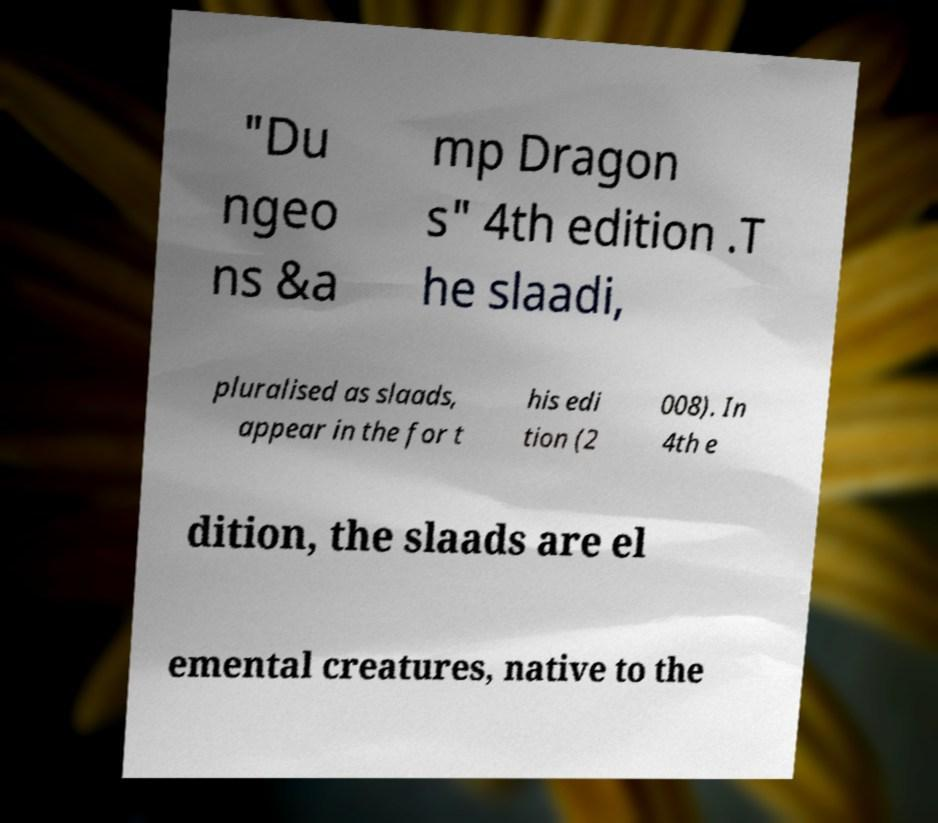Please identify and transcribe the text found in this image. "Du ngeo ns &a mp Dragon s" 4th edition .T he slaadi, pluralised as slaads, appear in the for t his edi tion (2 008). In 4th e dition, the slaads are el emental creatures, native to the 